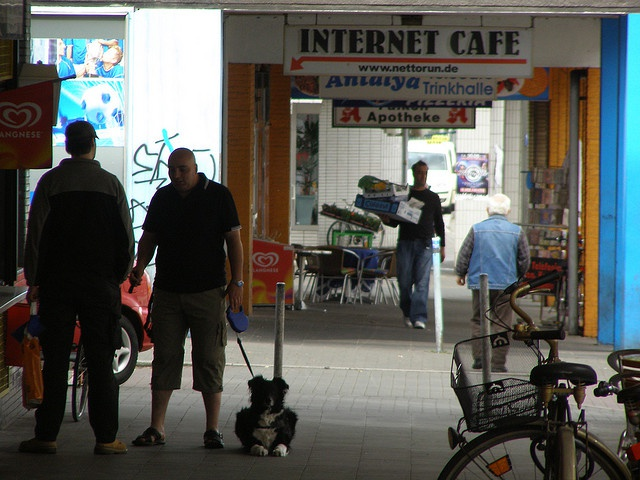Describe the objects in this image and their specific colors. I can see people in black, maroon, and gray tones, bicycle in black, gray, maroon, and darkgreen tones, people in black, maroon, and gray tones, people in black and gray tones, and people in black, gray, and blue tones in this image. 